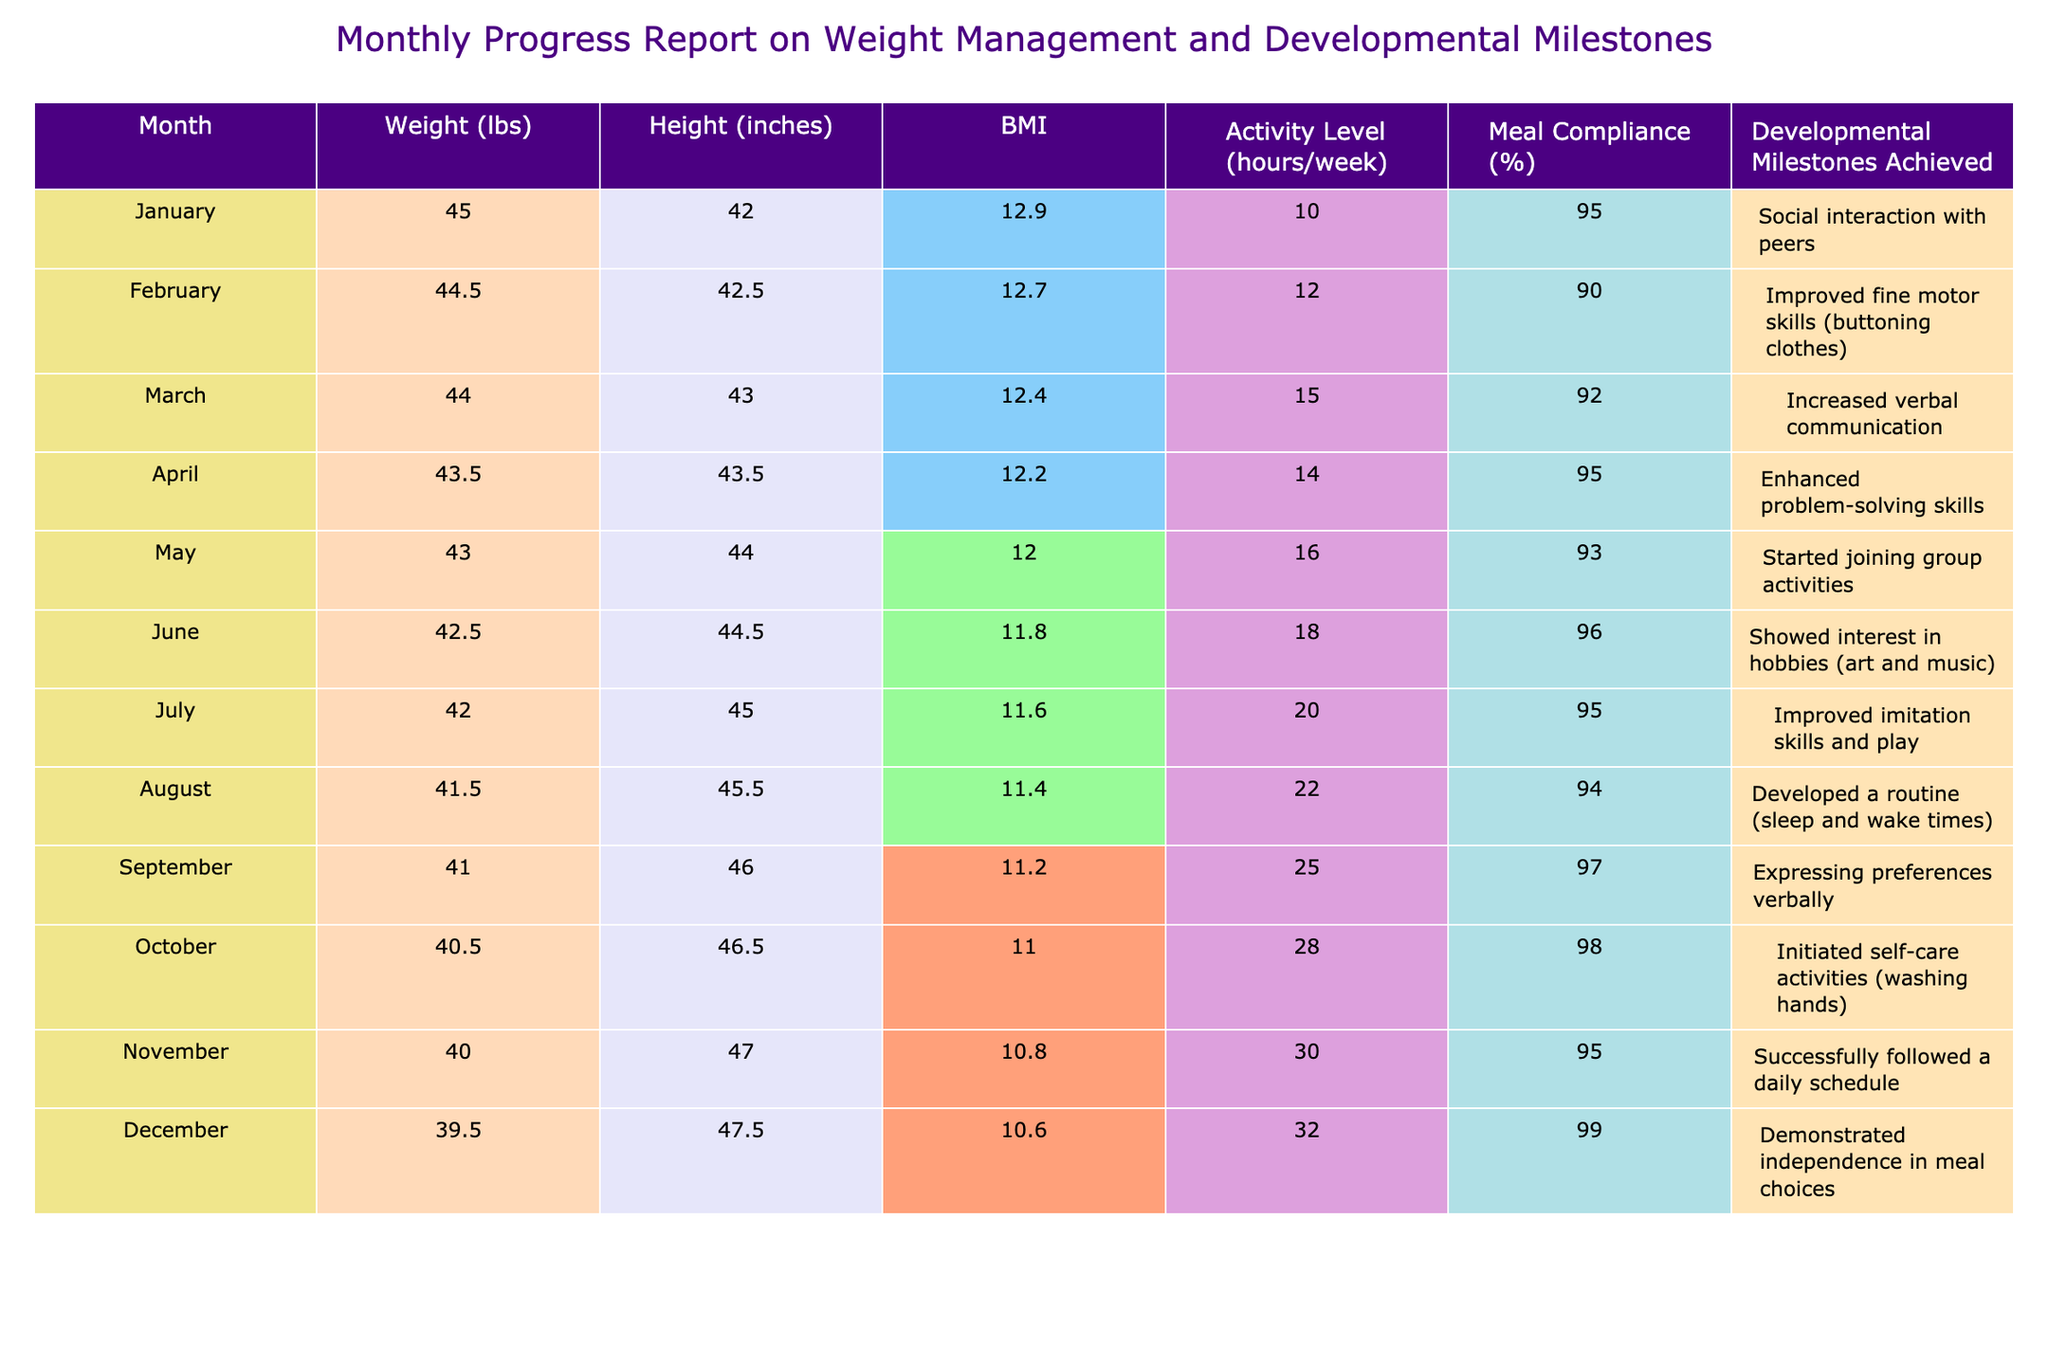What was the weight in December? The table shows that the weight in December is listed as 39.5 lbs.
Answer: 39.5 lbs What was the highest BMI recorded in the table? Looking through the BMI values, the highest recorded value is 12.9 in January.
Answer: 12.9 In which month was meal compliance at its highest? The table indicates that meal compliance was at 99% in December, which is the highest percentage shown.
Answer: 99% What was the average weight loss from January to December? The weight in January was 45 lbs and in December is 39.5 lbs. The weight loss is 45 - 39.5 = 5.5 lbs. To find the average monthly weight loss over 12 months, divide 5.5 lbs by 12 months: 5.5/12 ≈ 0.46 lbs/month.
Answer: 0.46 lbs/month How many developmental milestones were achieved by July? The table lists seven months from January to July, where each month shows a milestone achieved. By July, there are 7 milestones achieved up to that point.
Answer: 7 milestones Was there an increase in activity level from January to March? The activity levels are 10 hours/week in January, 12 hours/week in February, and 15 hours/week in March. Since 10 < 12 and 12 < 15, there is a clear increase in activity level from January to March.
Answer: Yes What was the change in height from January to October? The height in January is 42 inches and in October is 46.5 inches. The change is 46.5 - 42 = 4.5 inches.
Answer: 4.5 inches Which month had the lowest activity level? Reviewing the activity levels, January had the lowest at 10 hours/week.
Answer: January Did the developmental milestones achieved show improvement from February to June? In February, the milestone was "Improved fine motor skills," and by June, the milestone achieved is "Showed interest in hobbies." Each month shows progress, indicating a general improvement in skills and developmental progress.
Answer: Yes What was the total number of milestones achieved from January to December? Counting the milestones for each month from the table results in 12 milestones achieved—one for each month from January to December.
Answer: 12 milestones 